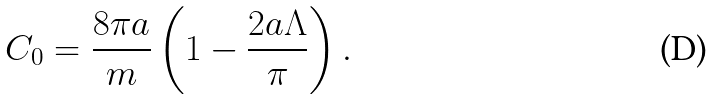<formula> <loc_0><loc_0><loc_500><loc_500>C _ { 0 } = \frac { 8 \pi a } { m } \left ( 1 - \frac { 2 a \Lambda } { \pi } \right ) .</formula> 